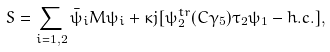Convert formula to latex. <formula><loc_0><loc_0><loc_500><loc_500>S = \sum _ { i = 1 , 2 } \bar { \psi } _ { i } M \psi _ { i } + \kappa j [ \psi _ { 2 } ^ { t r } ( C \gamma _ { 5 } ) \tau _ { 2 } \psi _ { 1 } - h . c . ] ,</formula> 